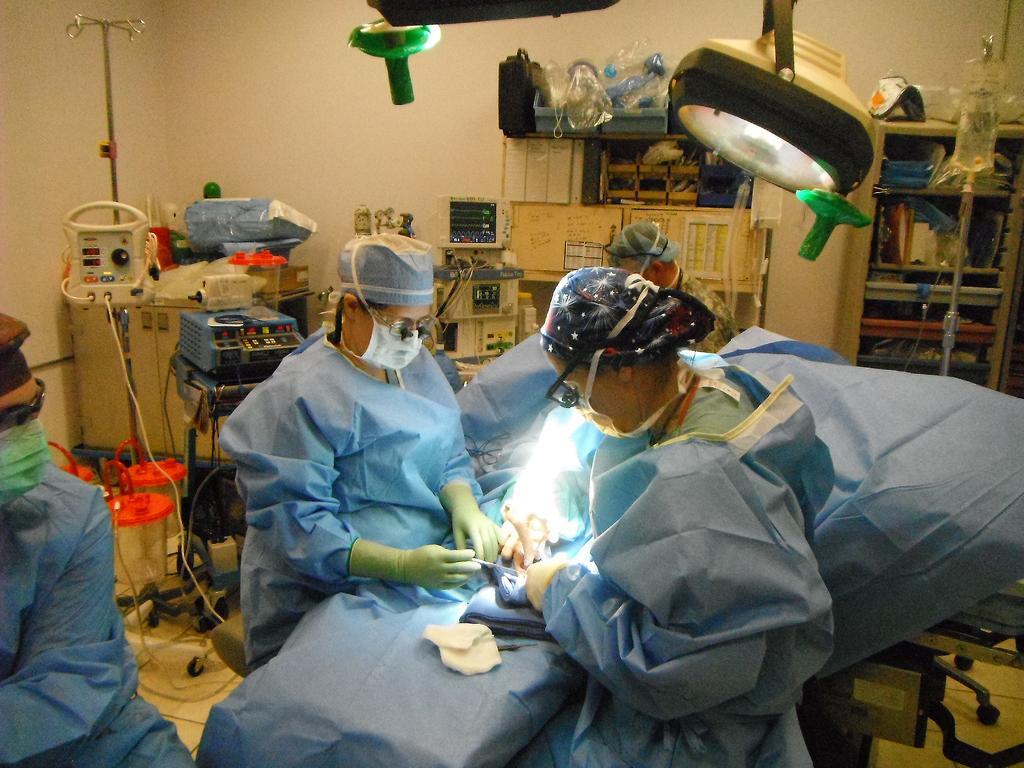How would you summarize this image in a sentence or two? In this image, I can see a group of people. At the top of the image, there are surgical lights. In the background, I can see the equipments, a rack, a wall and few other objects. 